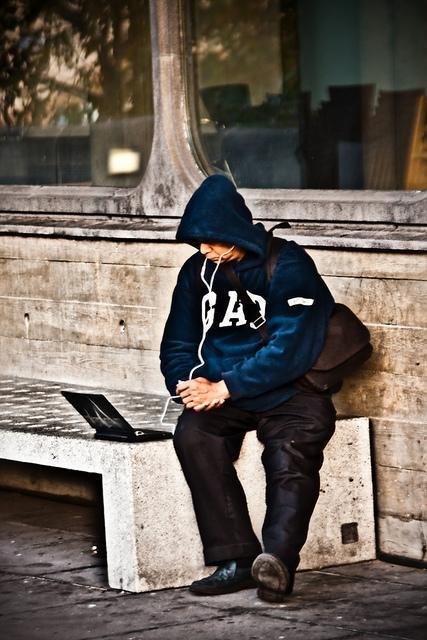What is the man sitting there doing?
Select the correct answer and articulate reasoning with the following format: 'Answer: answer
Rationale: rationale.'
Options: Preparing powerpoint, watching video, preparing document, sending email. Answer: watching video.
Rationale: He has headphones in and is staring at the screen instead of typing on the keyboard. 